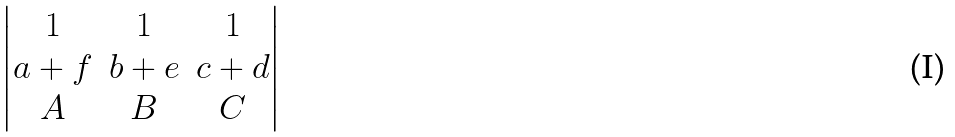Convert formula to latex. <formula><loc_0><loc_0><loc_500><loc_500>\begin{vmatrix} 1 & 1 & 1 \\ a + f & b + e & c + d \\ A & B & C \end{vmatrix}</formula> 